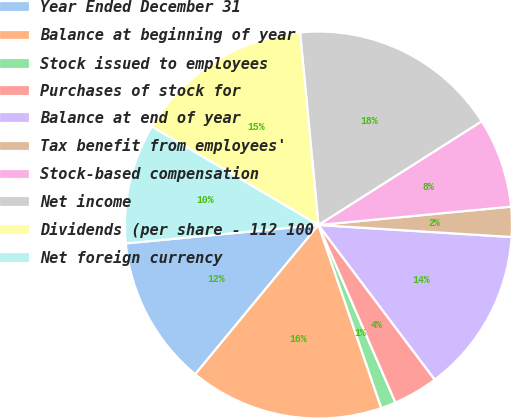Convert chart to OTSL. <chart><loc_0><loc_0><loc_500><loc_500><pie_chart><fcel>Year Ended December 31<fcel>Balance at beginning of year<fcel>Stock issued to employees<fcel>Purchases of stock for<fcel>Balance at end of year<fcel>Tax benefit from employees'<fcel>Stock-based compensation<fcel>Net income<fcel>Dividends (per share - 112 100<fcel>Net foreign currency<nl><fcel>12.5%<fcel>16.25%<fcel>1.25%<fcel>3.75%<fcel>13.75%<fcel>2.5%<fcel>7.5%<fcel>17.5%<fcel>15.0%<fcel>10.0%<nl></chart> 